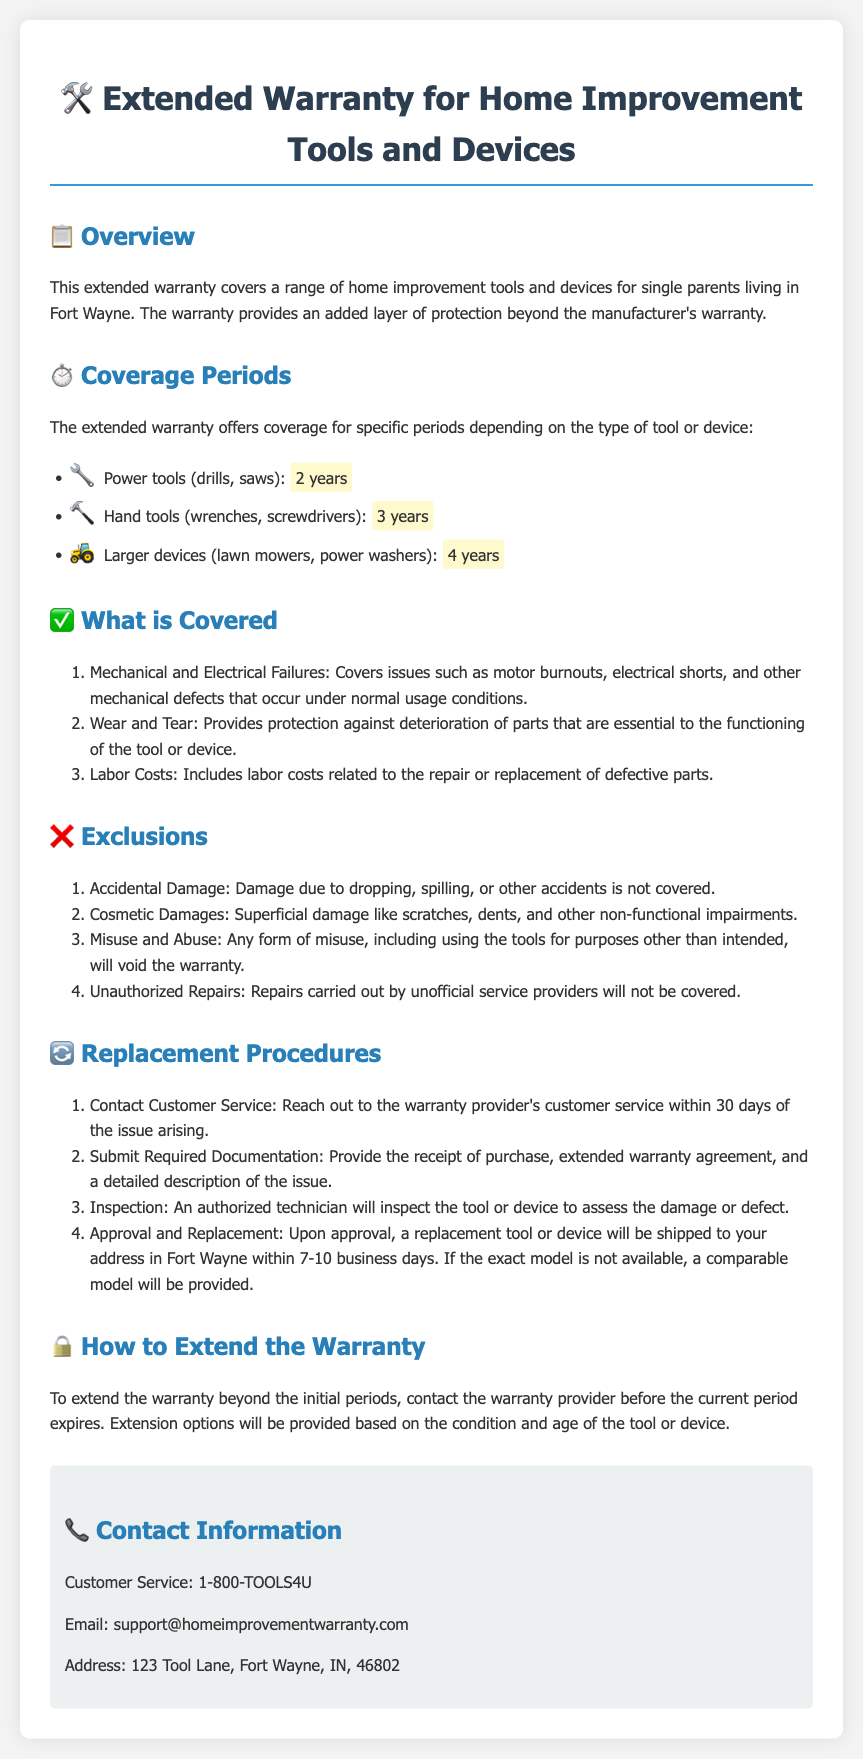What is the coverage period for power tools? The coverage period for power tools, such as drills and saws, is specified in the document as 2 years.
Answer: 2 years What types of damages are excluded from coverage? The document lists specific exclusions, which include accidental damage, cosmetic damages, misuse, and unauthorized repairs.
Answer: Accidental damage, cosmetic damages, misuse, unauthorized repairs How long does it take to receive a replacement tool? The document states that a replacement tool or device will be shipped within 7-10 business days after approval.
Answer: 7-10 business days What type of failures does the warranty cover? The warranty specifically covers mechanical and electrical failures, as outlined in the coverage section of the document.
Answer: Mechanical and electrical failures How can the warranty be extended? The document indicates that to extend the warranty, one must contact the warranty provider before the current period expires.
Answer: Contact the warranty provider before expiration What is the coverage period for hand tools? The document indicates that hand tools, such as wrenches and screwdrivers, have a coverage period of 3 years.
Answer: 3 years What must be submitted to initiate a replacement procedure? According to the document, required documentation includes the receipt of purchase, warranty agreement, and a description of the issue.
Answer: Receipt, warranty agreement, description of the issue Who should be contacted for customer support? The document lists the customer service number and email for customer support as the primary contact for inquiries.
Answer: 1-800-TOOLS4U, support@homeimprovementwarranty.com 